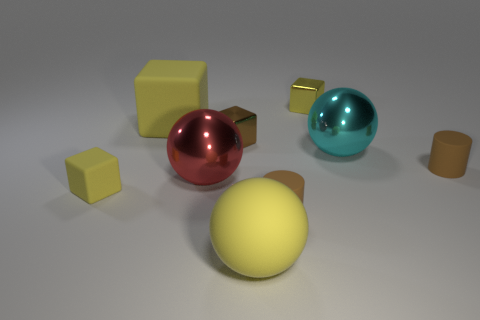There is a ball that is the same color as the big cube; what is its size?
Make the answer very short. Large. Is there a brown metallic object that has the same shape as the large red thing?
Make the answer very short. No. What number of objects are large yellow rubber cubes or small metallic things?
Provide a succinct answer. 3. How many tiny things are to the left of the big shiny object that is to the left of the cube right of the large yellow sphere?
Your answer should be compact. 1. There is a yellow thing that is the same shape as the large cyan object; what is it made of?
Provide a short and direct response. Rubber. There is a small thing that is behind the large red ball and in front of the large cyan sphere; what material is it made of?
Give a very brief answer. Rubber. Are there fewer yellow things that are to the right of the tiny brown shiny block than yellow matte spheres that are right of the cyan sphere?
Offer a terse response. No. What number of other things are there of the same size as the cyan thing?
Your answer should be very brief. 3. What is the shape of the small brown thing to the left of the big rubber object to the right of the large metal sphere that is in front of the big cyan object?
Offer a terse response. Cube. How many brown things are shiny blocks or tiny matte things?
Keep it short and to the point. 3. 